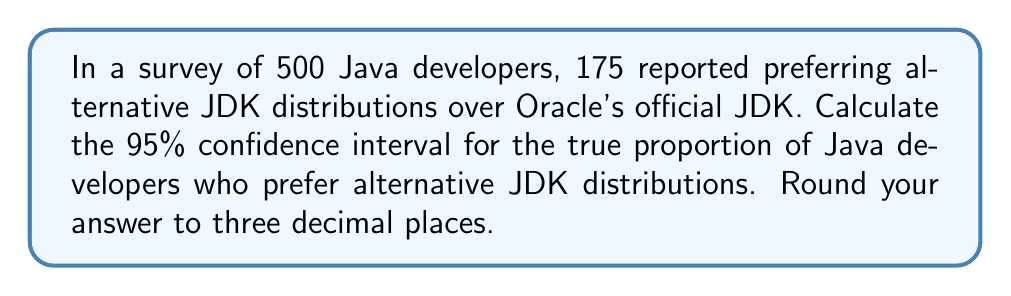Provide a solution to this math problem. Let's approach this step-by-step:

1) First, we need to calculate the sample proportion:
   $\hat{p} = \frac{175}{500} = 0.35$

2) For a 95% confidence interval, we use $z = 1.96$

3) The formula for the confidence interval is:
   $$\hat{p} \pm z\sqrt{\frac{\hat{p}(1-\hat{p})}{n}}$$

4) Let's calculate the margin of error:
   $$\text{ME} = 1.96\sqrt{\frac{0.35(1-0.35)}{500}}$$
   $$= 1.96\sqrt{\frac{0.2275}{500}}$$
   $$= 1.96\sqrt{0.000455}$$
   $$= 1.96 * 0.02133$$
   $$= 0.04181$$

5) Now, we can calculate the confidence interval:
   Lower bound: $0.35 - 0.04181 = 0.30819$
   Upper bound: $0.35 + 0.04181 = 0.39181$

6) Rounding to three decimal places:
   (0.308, 0.392)

This means we can be 95% confident that the true proportion of Java developers who prefer alternative JDK distributions is between 30.8% and 39.2%.
Answer: (0.308, 0.392) 